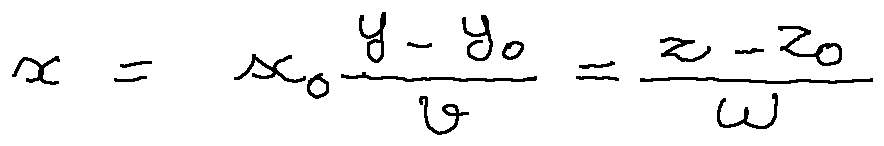<formula> <loc_0><loc_0><loc_500><loc_500>x = x _ { 0 } \frac { y - y _ { 0 } } { v } = \frac { z - z _ { 0 } } { w }</formula> 